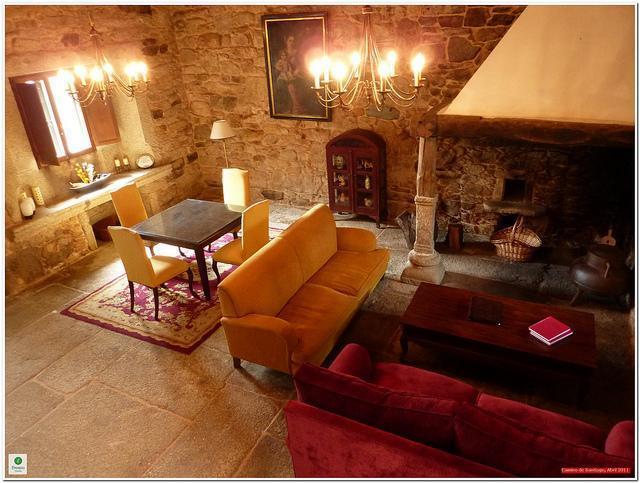How many people can sit at the dining table?
Give a very brief answer. 4. How many couches are visible?
Give a very brief answer. 2. How many dining tables can you see?
Give a very brief answer. 2. How many of the train carts have red around the windows?
Give a very brief answer. 0. 